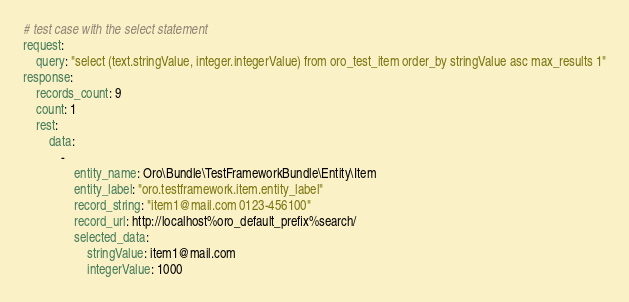<code> <loc_0><loc_0><loc_500><loc_500><_YAML_># test case with the select statement
request:
    query: "select (text.stringValue, integer.integerValue) from oro_test_item order_by stringValue asc max_results 1"
response:
    records_count: 9
    count: 1
    rest:
        data:
            -
                entity_name: Oro\Bundle\TestFrameworkBundle\Entity\Item
                entity_label: "oro.testframework.item.entity_label"
                record_string: "item1@mail.com 0123-456100"
                record_url: http://localhost%oro_default_prefix%search/
                selected_data:
                    stringValue: item1@mail.com
                    integerValue: 1000
</code> 